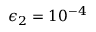Convert formula to latex. <formula><loc_0><loc_0><loc_500><loc_500>\epsilon _ { 2 } = 1 0 ^ { - 4 }</formula> 